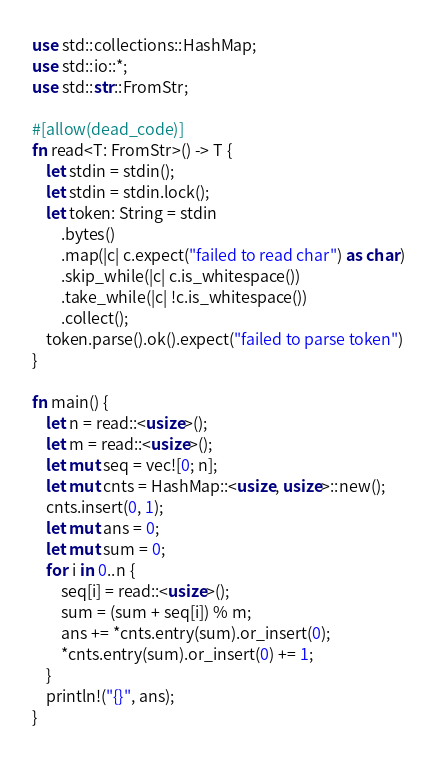<code> <loc_0><loc_0><loc_500><loc_500><_Rust_>use std::collections::HashMap;
use std::io::*;
use std::str::FromStr;

#[allow(dead_code)]
fn read<T: FromStr>() -> T {
    let stdin = stdin();
    let stdin = stdin.lock();
    let token: String = stdin
        .bytes()
        .map(|c| c.expect("failed to read char") as char)
        .skip_while(|c| c.is_whitespace())
        .take_while(|c| !c.is_whitespace())
        .collect();
    token.parse().ok().expect("failed to parse token")
}

fn main() {
    let n = read::<usize>();
    let m = read::<usize>();
    let mut seq = vec![0; n];
    let mut cnts = HashMap::<usize, usize>::new();
    cnts.insert(0, 1);
    let mut ans = 0;
    let mut sum = 0;
    for i in 0..n {
        seq[i] = read::<usize>();
        sum = (sum + seq[i]) % m;
        ans += *cnts.entry(sum).or_insert(0);
        *cnts.entry(sum).or_insert(0) += 1;
    }
    println!("{}", ans);
}
</code> 